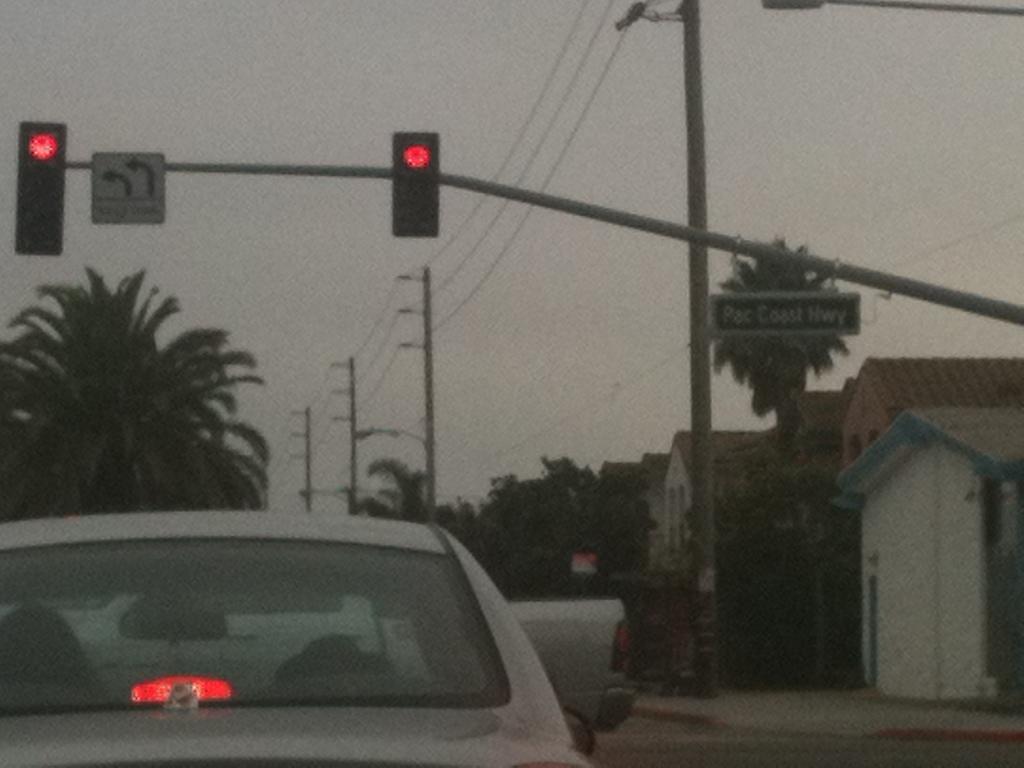What highway are they on?
Ensure brevity in your answer.  Pac coast hwy. 